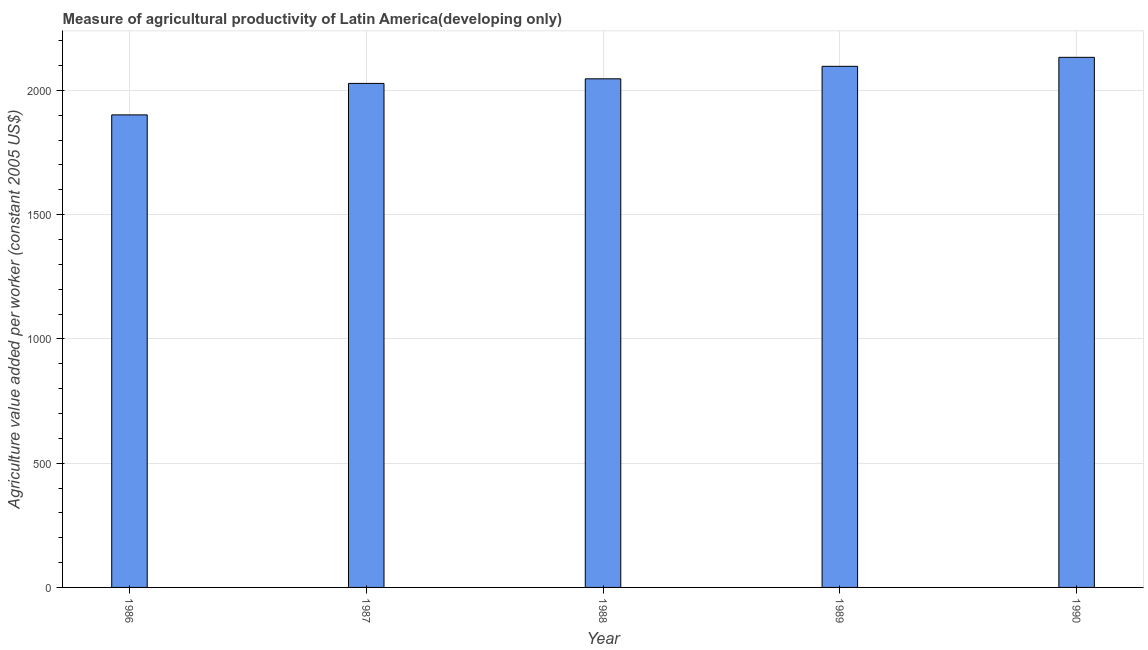What is the title of the graph?
Offer a terse response. Measure of agricultural productivity of Latin America(developing only). What is the label or title of the X-axis?
Give a very brief answer. Year. What is the label or title of the Y-axis?
Ensure brevity in your answer.  Agriculture value added per worker (constant 2005 US$). What is the agriculture value added per worker in 1986?
Your answer should be compact. 1901.68. Across all years, what is the maximum agriculture value added per worker?
Offer a very short reply. 2133.3. Across all years, what is the minimum agriculture value added per worker?
Ensure brevity in your answer.  1901.68. In which year was the agriculture value added per worker maximum?
Offer a terse response. 1990. What is the sum of the agriculture value added per worker?
Provide a succinct answer. 1.02e+04. What is the difference between the agriculture value added per worker in 1986 and 1989?
Your answer should be compact. -195.4. What is the average agriculture value added per worker per year?
Ensure brevity in your answer.  2041.46. What is the median agriculture value added per worker?
Give a very brief answer. 2046.89. In how many years, is the agriculture value added per worker greater than 400 US$?
Your answer should be compact. 5. Do a majority of the years between 1988 and 1989 (inclusive) have agriculture value added per worker greater than 2000 US$?
Offer a terse response. Yes. What is the ratio of the agriculture value added per worker in 1986 to that in 1990?
Your response must be concise. 0.89. What is the difference between the highest and the second highest agriculture value added per worker?
Ensure brevity in your answer.  36.21. What is the difference between the highest and the lowest agriculture value added per worker?
Your answer should be very brief. 231.62. In how many years, is the agriculture value added per worker greater than the average agriculture value added per worker taken over all years?
Ensure brevity in your answer.  3. How many bars are there?
Your answer should be compact. 5. Are all the bars in the graph horizontal?
Provide a succinct answer. No. How many years are there in the graph?
Give a very brief answer. 5. What is the Agriculture value added per worker (constant 2005 US$) of 1986?
Keep it short and to the point. 1901.68. What is the Agriculture value added per worker (constant 2005 US$) in 1987?
Ensure brevity in your answer.  2028.33. What is the Agriculture value added per worker (constant 2005 US$) of 1988?
Your answer should be compact. 2046.89. What is the Agriculture value added per worker (constant 2005 US$) of 1989?
Your answer should be compact. 2097.09. What is the Agriculture value added per worker (constant 2005 US$) in 1990?
Your response must be concise. 2133.3. What is the difference between the Agriculture value added per worker (constant 2005 US$) in 1986 and 1987?
Keep it short and to the point. -126.64. What is the difference between the Agriculture value added per worker (constant 2005 US$) in 1986 and 1988?
Offer a terse response. -145.21. What is the difference between the Agriculture value added per worker (constant 2005 US$) in 1986 and 1989?
Offer a terse response. -195.4. What is the difference between the Agriculture value added per worker (constant 2005 US$) in 1986 and 1990?
Your answer should be compact. -231.62. What is the difference between the Agriculture value added per worker (constant 2005 US$) in 1987 and 1988?
Ensure brevity in your answer.  -18.56. What is the difference between the Agriculture value added per worker (constant 2005 US$) in 1987 and 1989?
Make the answer very short. -68.76. What is the difference between the Agriculture value added per worker (constant 2005 US$) in 1987 and 1990?
Ensure brevity in your answer.  -104.97. What is the difference between the Agriculture value added per worker (constant 2005 US$) in 1988 and 1989?
Offer a very short reply. -50.2. What is the difference between the Agriculture value added per worker (constant 2005 US$) in 1988 and 1990?
Make the answer very short. -86.41. What is the difference between the Agriculture value added per worker (constant 2005 US$) in 1989 and 1990?
Ensure brevity in your answer.  -36.21. What is the ratio of the Agriculture value added per worker (constant 2005 US$) in 1986 to that in 1987?
Keep it short and to the point. 0.94. What is the ratio of the Agriculture value added per worker (constant 2005 US$) in 1986 to that in 1988?
Offer a terse response. 0.93. What is the ratio of the Agriculture value added per worker (constant 2005 US$) in 1986 to that in 1989?
Keep it short and to the point. 0.91. What is the ratio of the Agriculture value added per worker (constant 2005 US$) in 1986 to that in 1990?
Make the answer very short. 0.89. What is the ratio of the Agriculture value added per worker (constant 2005 US$) in 1987 to that in 1990?
Provide a succinct answer. 0.95. 